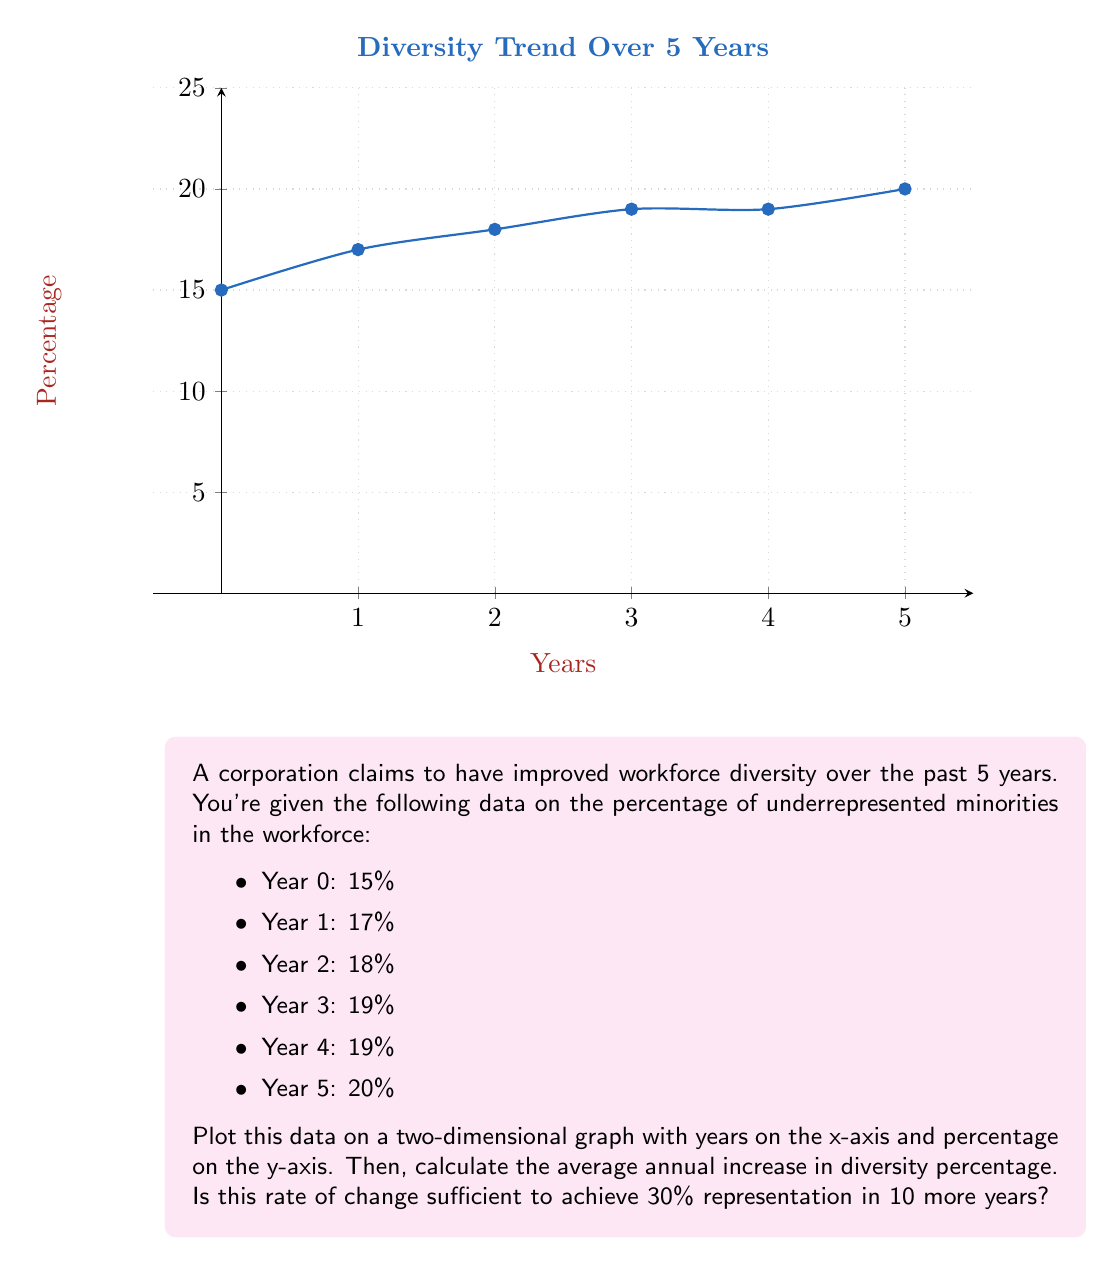Help me with this question. Let's approach this step-by-step:

1) First, we plot the data points on the graph as shown.

2) To calculate the average annual increase:
   
   Total increase = Final percentage - Initial percentage
                  = 20% - 15% = 5%
   
   Average annual increase = Total increase / Number of years
                           = 5% / 5 years
                           = 1% per year

3) Now, let's determine if this rate is sufficient to reach 30% in 10 more years:

   Current percentage = 20%
   Desired increase = 30% - 20% = 10%
   
   Years needed at current rate = Desired increase / Annual increase
                                = 10% / 1% per year
                                = 10 years

4) Therefore, at the current rate, it would take exactly 10 years to reach 30%.

5) However, as a union representative skeptical of the corporation's commitment, we should note:
   - The rate of increase has been slowing down (from 2% in the first year to 1% in the last year).
   - There was no increase between Year 3 and Year 4.
   - The total increase over 5 years (5%) is less than what's needed for the next 10 years (10%).

6) Given these observations, it's unlikely that the current trend will continue at a steady 1% per year. The corporation would need to significantly improve its diversity efforts to achieve the 30% goal in 10 years.
Answer: Average annual increase: 1%. Not sufficient for 30% in 10 years given slowing trend. 